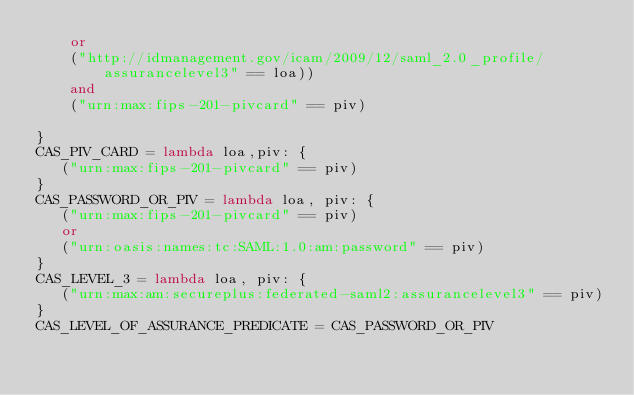Convert code to text. <code><loc_0><loc_0><loc_500><loc_500><_Python_>    or
    ("http://idmanagement.gov/icam/2009/12/saml_2.0_profile/assurancelevel3" == loa))
    and
    ("urn:max:fips-201-pivcard" == piv)

}
CAS_PIV_CARD = lambda loa,piv: {
   ("urn:max:fips-201-pivcard" == piv)
}
CAS_PASSWORD_OR_PIV = lambda loa, piv: {
   ("urn:max:fips-201-pivcard" == piv)
   or
   ("urn:oasis:names:tc:SAML:1.0:am:password" == piv)
}
CAS_LEVEL_3 = lambda loa, piv: {
   ("urn:max:am:secureplus:federated-saml2:assurancelevel3" == piv)
}
CAS_LEVEL_OF_ASSURANCE_PREDICATE = CAS_PASSWORD_OR_PIV


</code> 